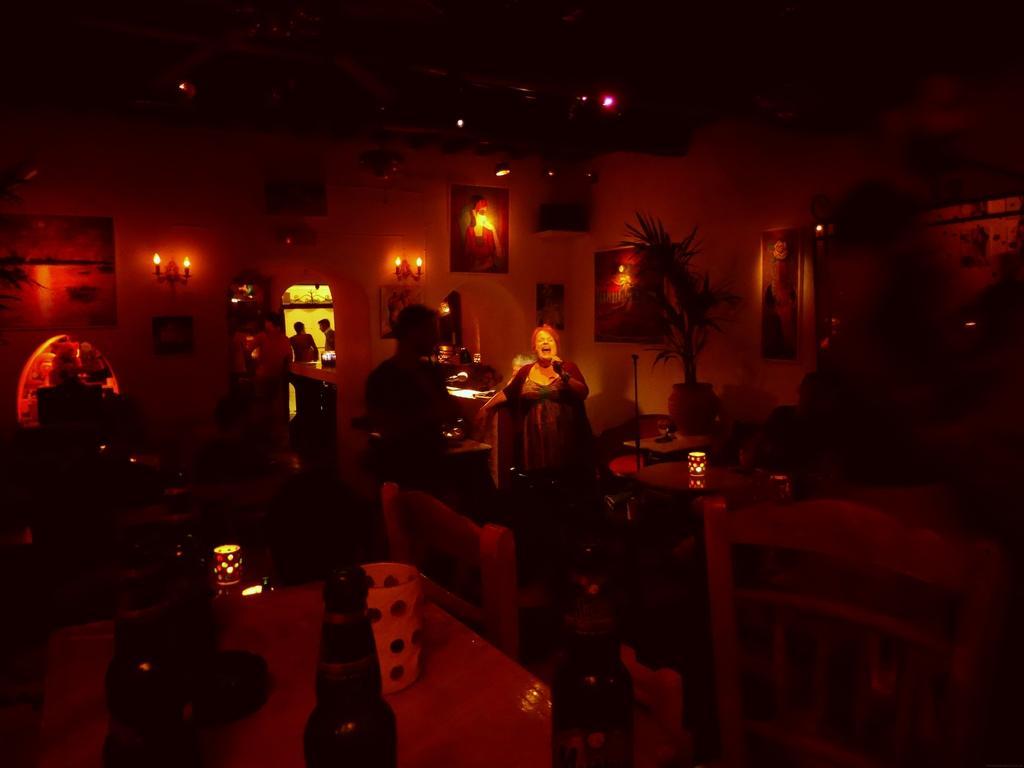Could you give a brief overview of what you see in this image? In this image there are two women standing,the women is holding a microphone and singing,beside a woman there is plant in front of the women there is dining table, there is a bottle on the table. There are two men standing in the image. At the background there is a frame and a light attached to the wall. 